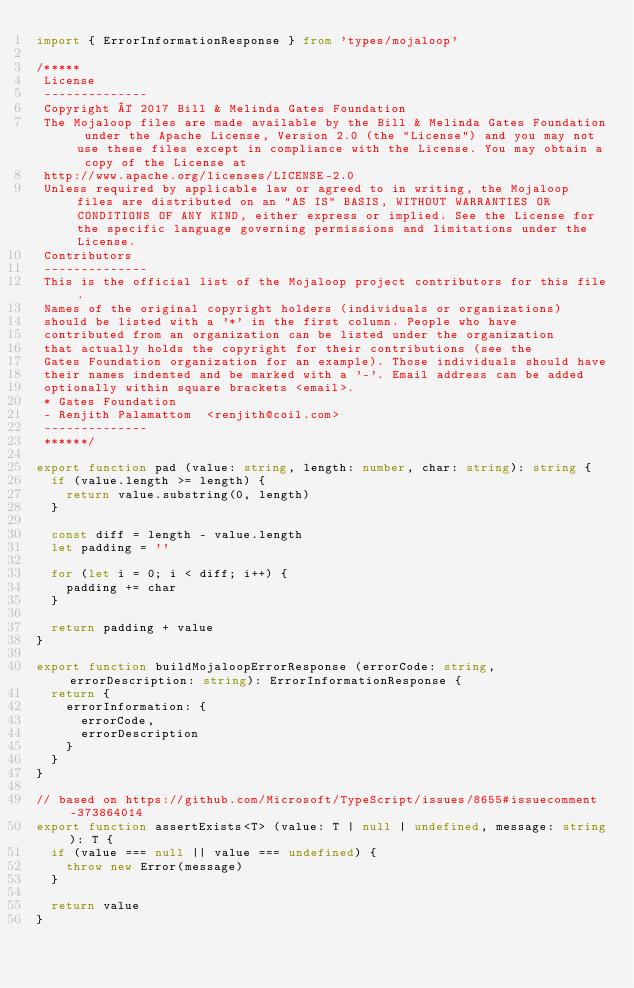<code> <loc_0><loc_0><loc_500><loc_500><_TypeScript_>import { ErrorInformationResponse } from 'types/mojaloop'

/*****
 License
 --------------
 Copyright © 2017 Bill & Melinda Gates Foundation
 The Mojaloop files are made available by the Bill & Melinda Gates Foundation under the Apache License, Version 2.0 (the "License") and you may not use these files except in compliance with the License. You may obtain a copy of the License at
 http://www.apache.org/licenses/LICENSE-2.0
 Unless required by applicable law or agreed to in writing, the Mojaloop files are distributed on an "AS IS" BASIS, WITHOUT WARRANTIES OR CONDITIONS OF ANY KIND, either express or implied. See the License for the specific language governing permissions and limitations under the License.
 Contributors
 --------------
 This is the official list of the Mojaloop project contributors for this file.
 Names of the original copyright holders (individuals or organizations)
 should be listed with a '*' in the first column. People who have
 contributed from an organization can be listed under the organization
 that actually holds the copyright for their contributions (see the
 Gates Foundation organization for an example). Those individuals should have
 their names indented and be marked with a '-'. Email address can be added
 optionally within square brackets <email>.
 * Gates Foundation
 - Renjith Palamattom  <renjith@coil.com>
 --------------
 ******/

export function pad (value: string, length: number, char: string): string {
  if (value.length >= length) {
    return value.substring(0, length)
  }

  const diff = length - value.length
  let padding = ''

  for (let i = 0; i < diff; i++) {
    padding += char
  }

  return padding + value
}

export function buildMojaloopErrorResponse (errorCode: string, errorDescription: string): ErrorInformationResponse {
  return {
    errorInformation: {
      errorCode,
      errorDescription
    }
  }
}

// based on https://github.com/Microsoft/TypeScript/issues/8655#issuecomment-373864014
export function assertExists<T> (value: T | null | undefined, message: string): T {
  if (value === null || value === undefined) {
    throw new Error(message)
  }

  return value
}
</code> 